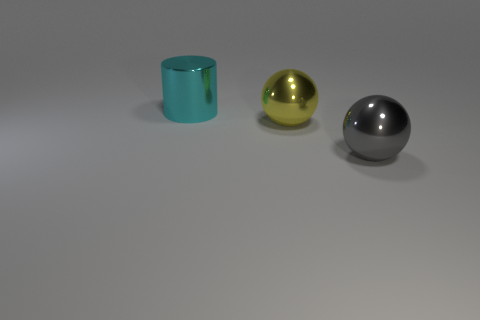Add 2 cyan things. How many objects exist? 5 Subtract all cylinders. How many objects are left? 2 Subtract all tiny gray rubber spheres. Subtract all large yellow things. How many objects are left? 2 Add 1 metal balls. How many metal balls are left? 3 Add 1 cyan cylinders. How many cyan cylinders exist? 2 Subtract 0 brown cubes. How many objects are left? 3 